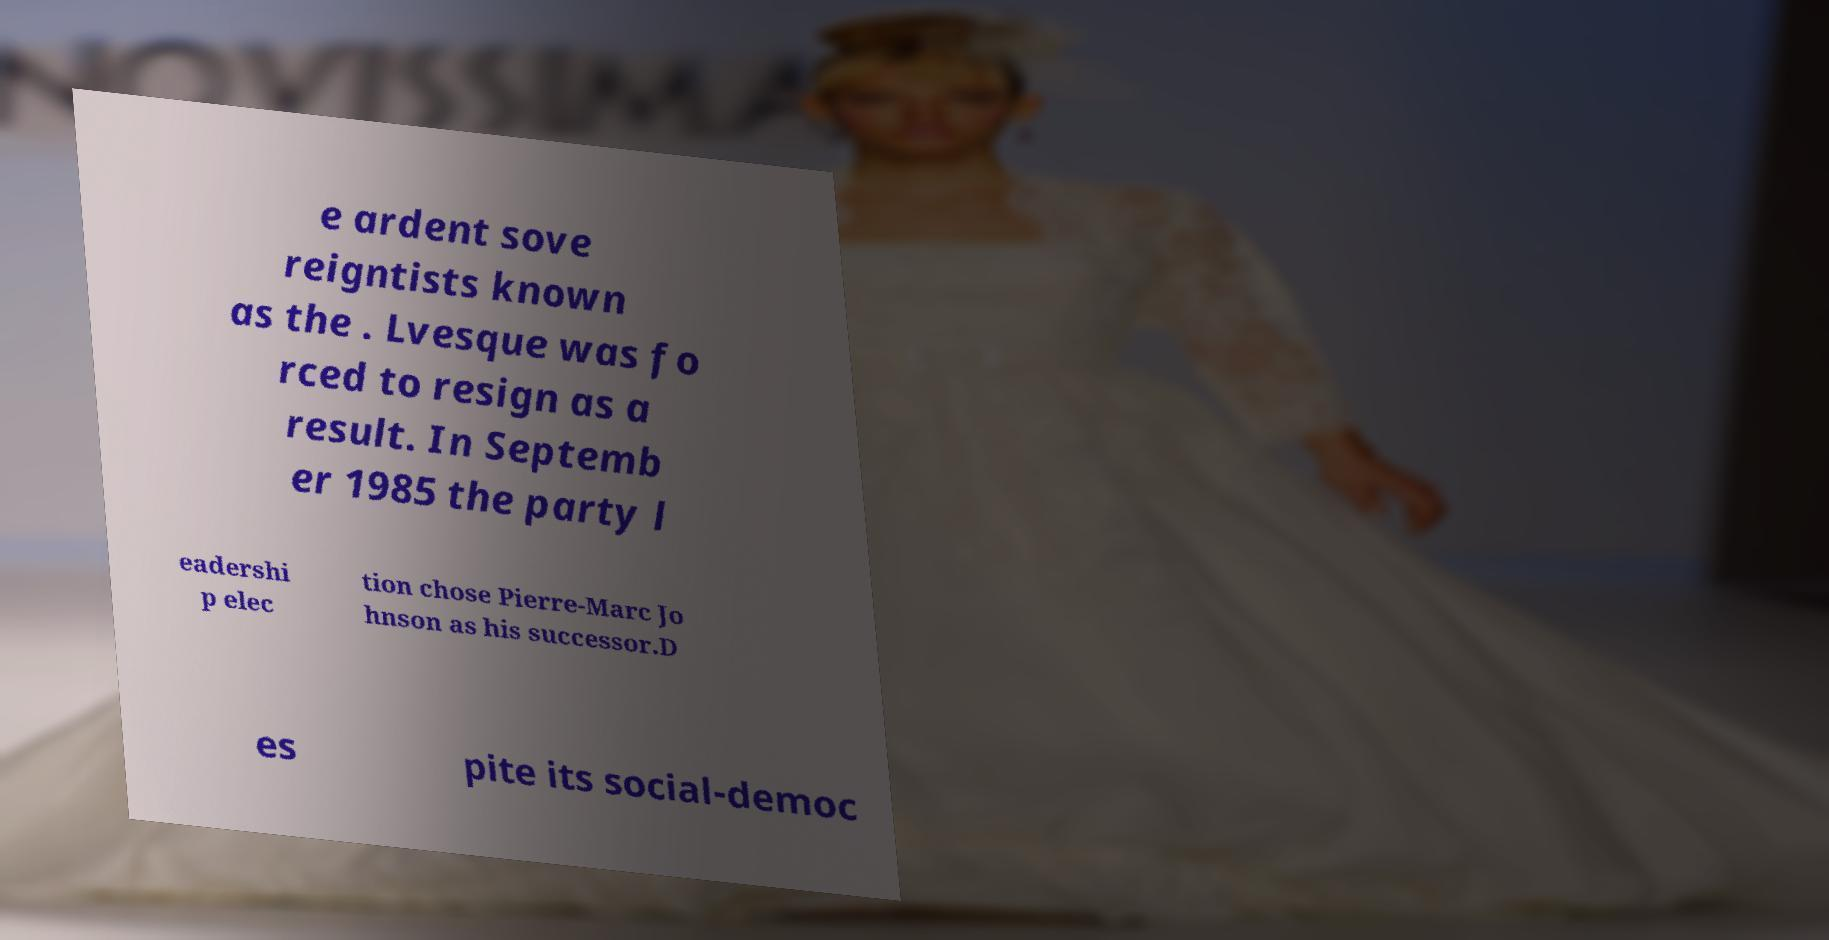Please identify and transcribe the text found in this image. e ardent sove reigntists known as the . Lvesque was fo rced to resign as a result. In Septemb er 1985 the party l eadershi p elec tion chose Pierre-Marc Jo hnson as his successor.D es pite its social-democ 